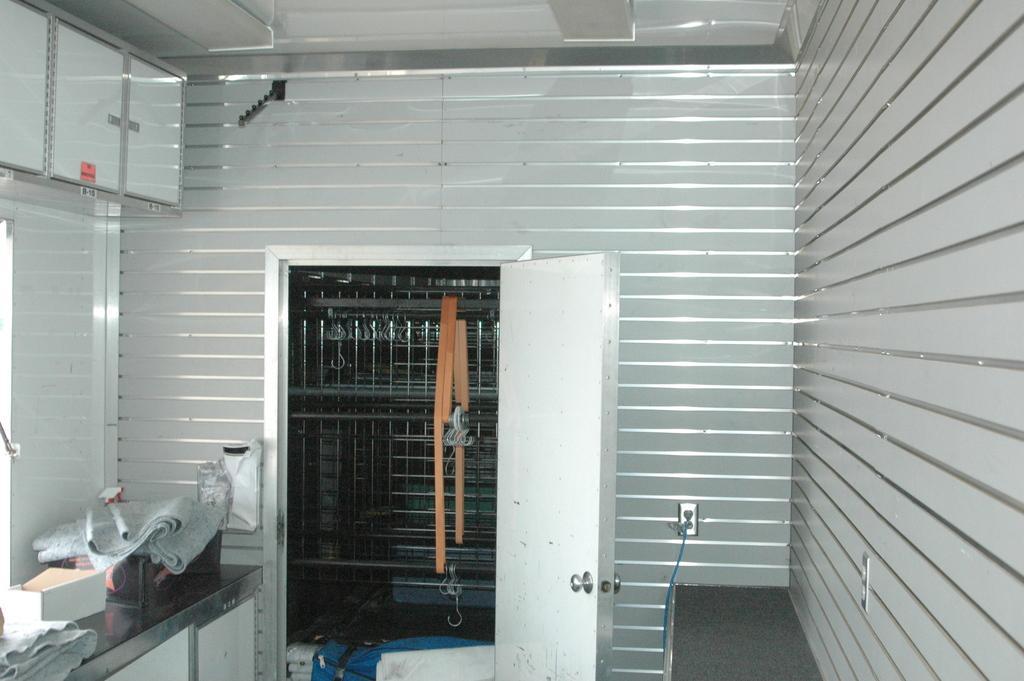Can you describe this image briefly? In this picture we can see the inside view of the kitchen. In the front there is a white door and behind a metal grill. In the front we can see a white color cladding tiles on the wall. On the top there is a cabinet door and on the left side we can see kitchen platform with brown box and white clothes. 